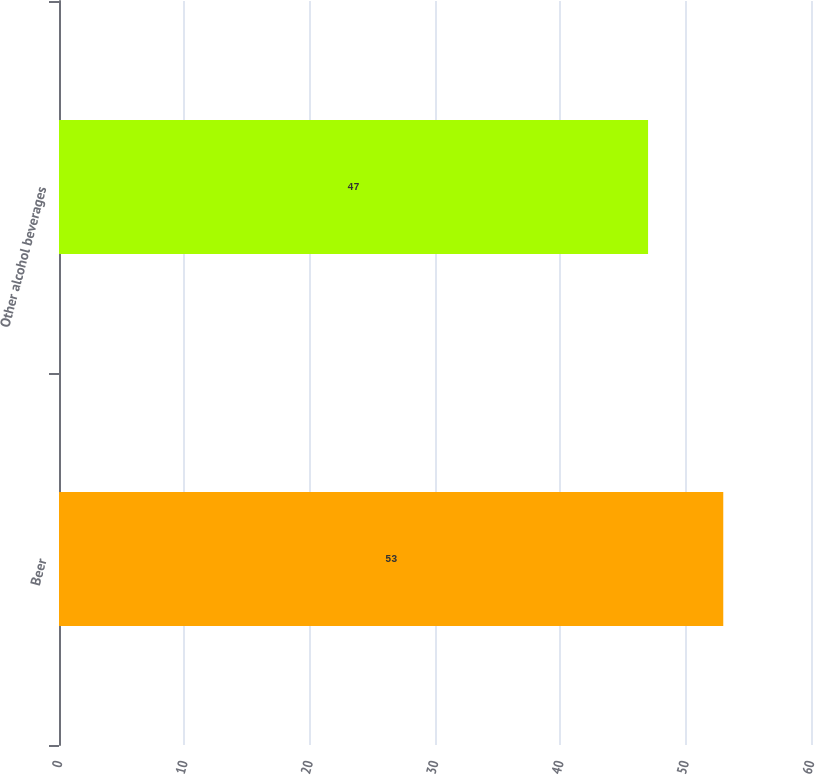Convert chart. <chart><loc_0><loc_0><loc_500><loc_500><bar_chart><fcel>Beer<fcel>Other alcohol beverages<nl><fcel>53<fcel>47<nl></chart> 